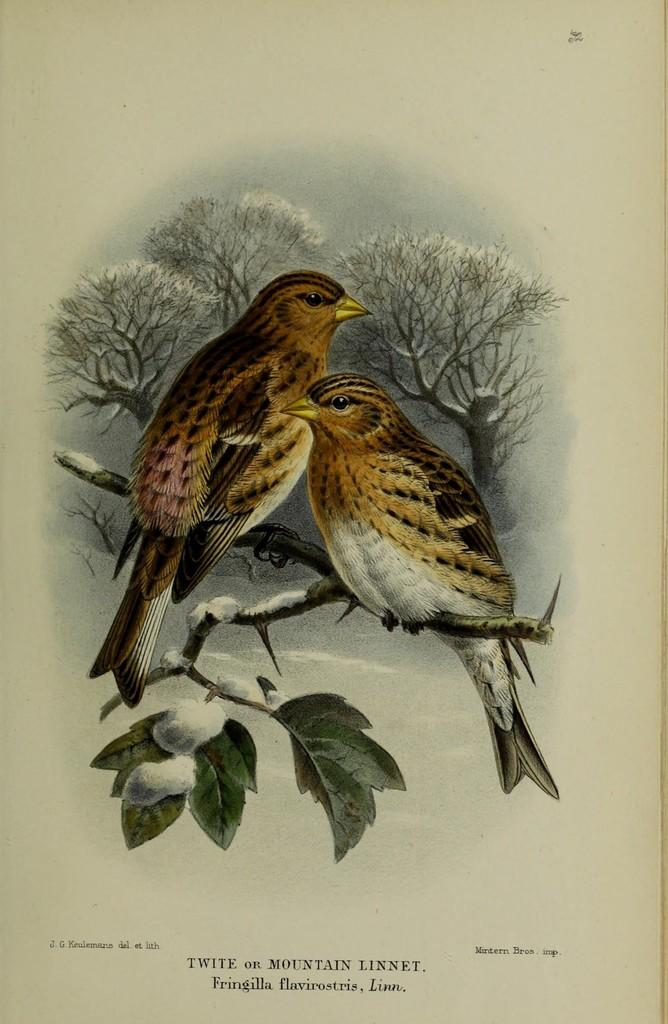What is present on the paper in the image? There is a painting on the paper in the image. Can you describe the painting on the paper? Unfortunately, the details of the painting cannot be determined from the provided facts. What is the primary purpose of the paper in the image? The primary purpose of the paper in the image is to serve as a canvas for the painting. What type of crib is depicted in the painting on the paper? There is no crib present in the image, as the painting on the paper cannot be described in detail based on the provided facts. 